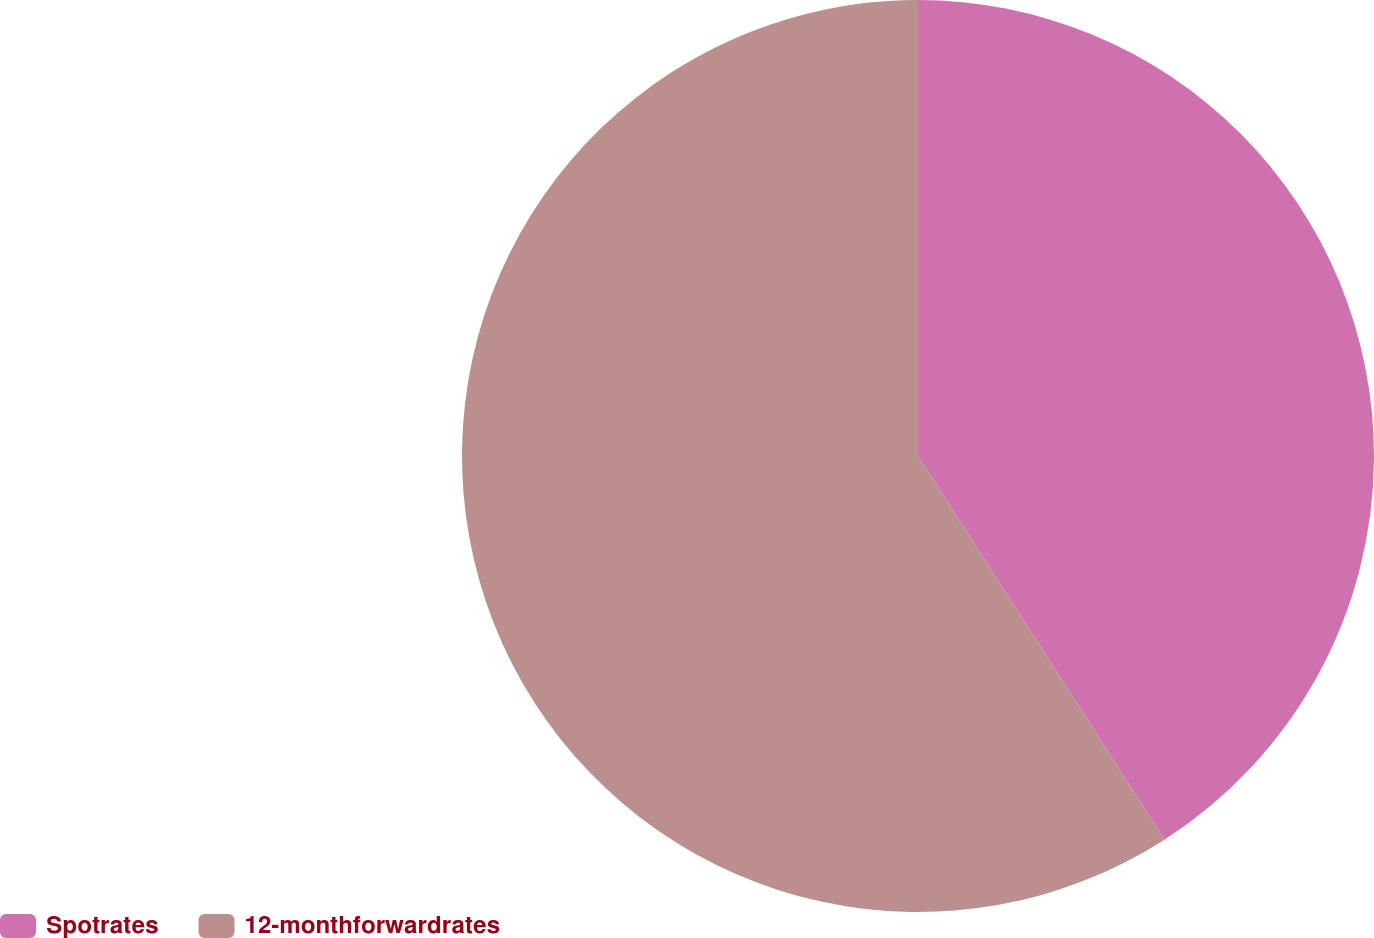Convert chart to OTSL. <chart><loc_0><loc_0><loc_500><loc_500><pie_chart><fcel>Spotrates<fcel>12-monthforwardrates<nl><fcel>40.91%<fcel>59.09%<nl></chart> 